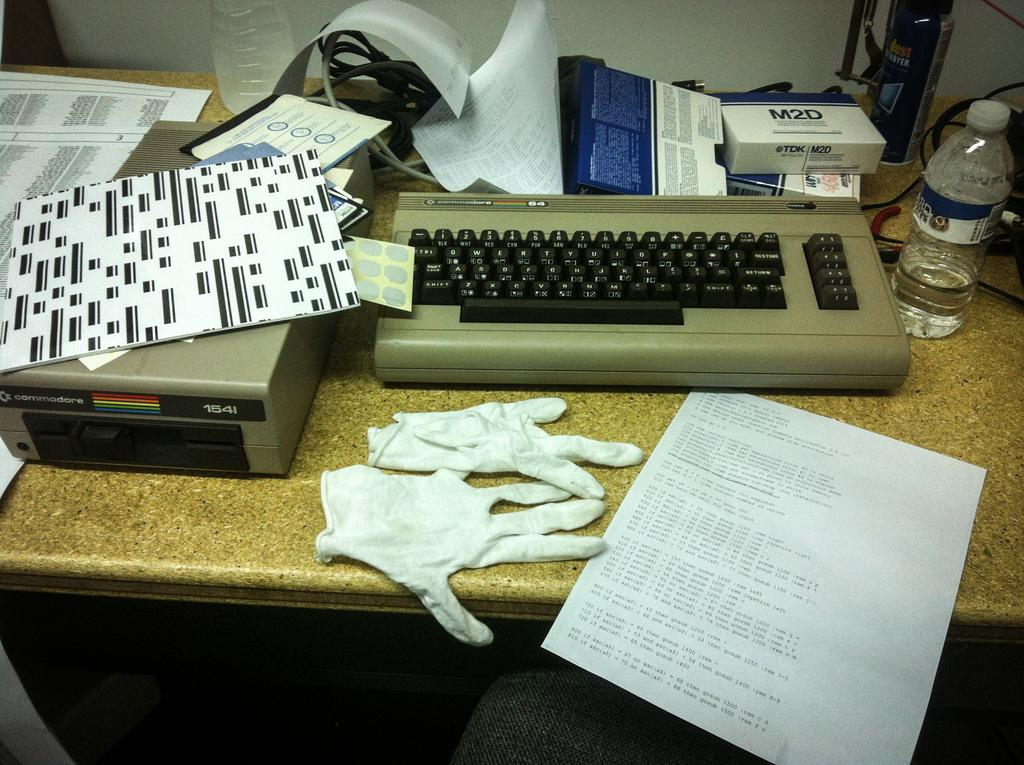What is the main object in the image? There is a table in the image. What is placed on the table? A keyboard, a water bottle, and papers are placed on the table. What type of arithmetic problem is being solved on the quilt in the image? There is no quilt or arithmetic problem present in the image. How many geese are visible on the table in the image? There are no geese visible on the table in the image. 